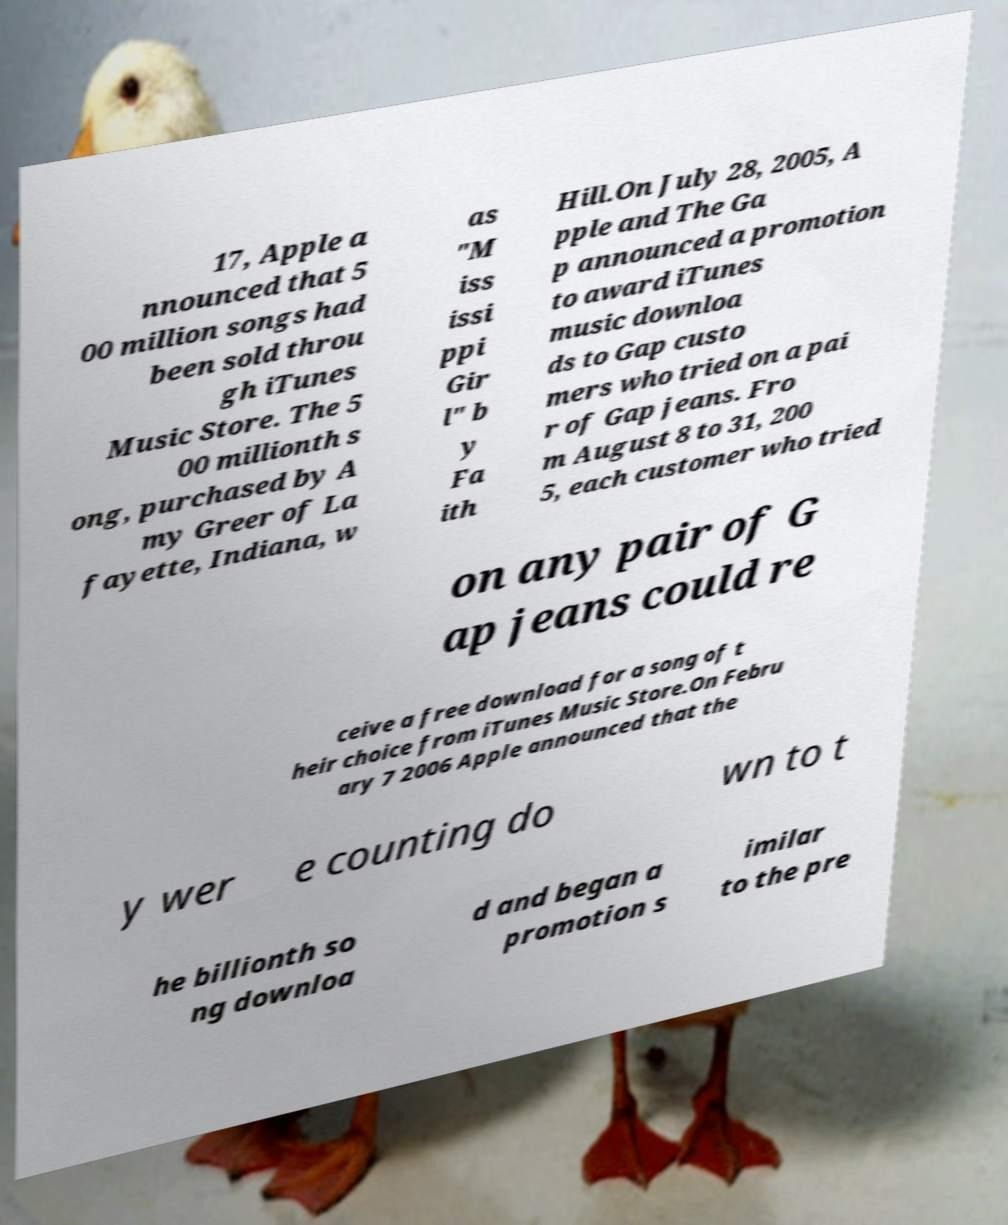Could you extract and type out the text from this image? 17, Apple a nnounced that 5 00 million songs had been sold throu gh iTunes Music Store. The 5 00 millionth s ong, purchased by A my Greer of La fayette, Indiana, w as "M iss issi ppi Gir l" b y Fa ith Hill.On July 28, 2005, A pple and The Ga p announced a promotion to award iTunes music downloa ds to Gap custo mers who tried on a pai r of Gap jeans. Fro m August 8 to 31, 200 5, each customer who tried on any pair of G ap jeans could re ceive a free download for a song of t heir choice from iTunes Music Store.On Febru ary 7 2006 Apple announced that the y wer e counting do wn to t he billionth so ng downloa d and began a promotion s imilar to the pre 